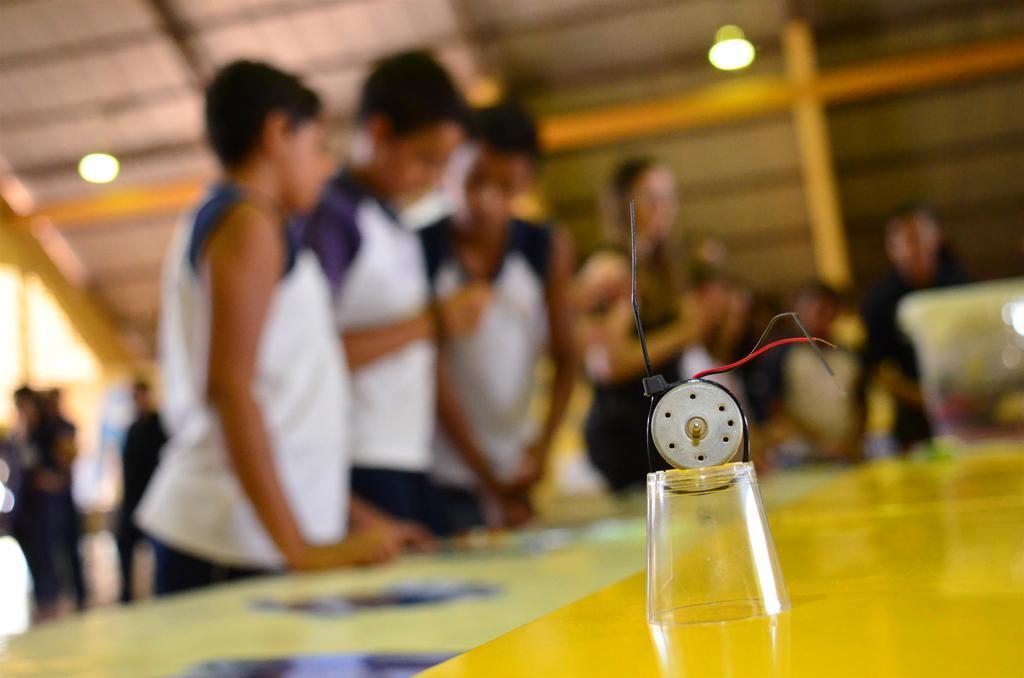Please provide a concise description of this image. There is a table. On that there is a glass with wires and some other items. In the background there are many people and it is blurred. On the ceiling there are lights. 